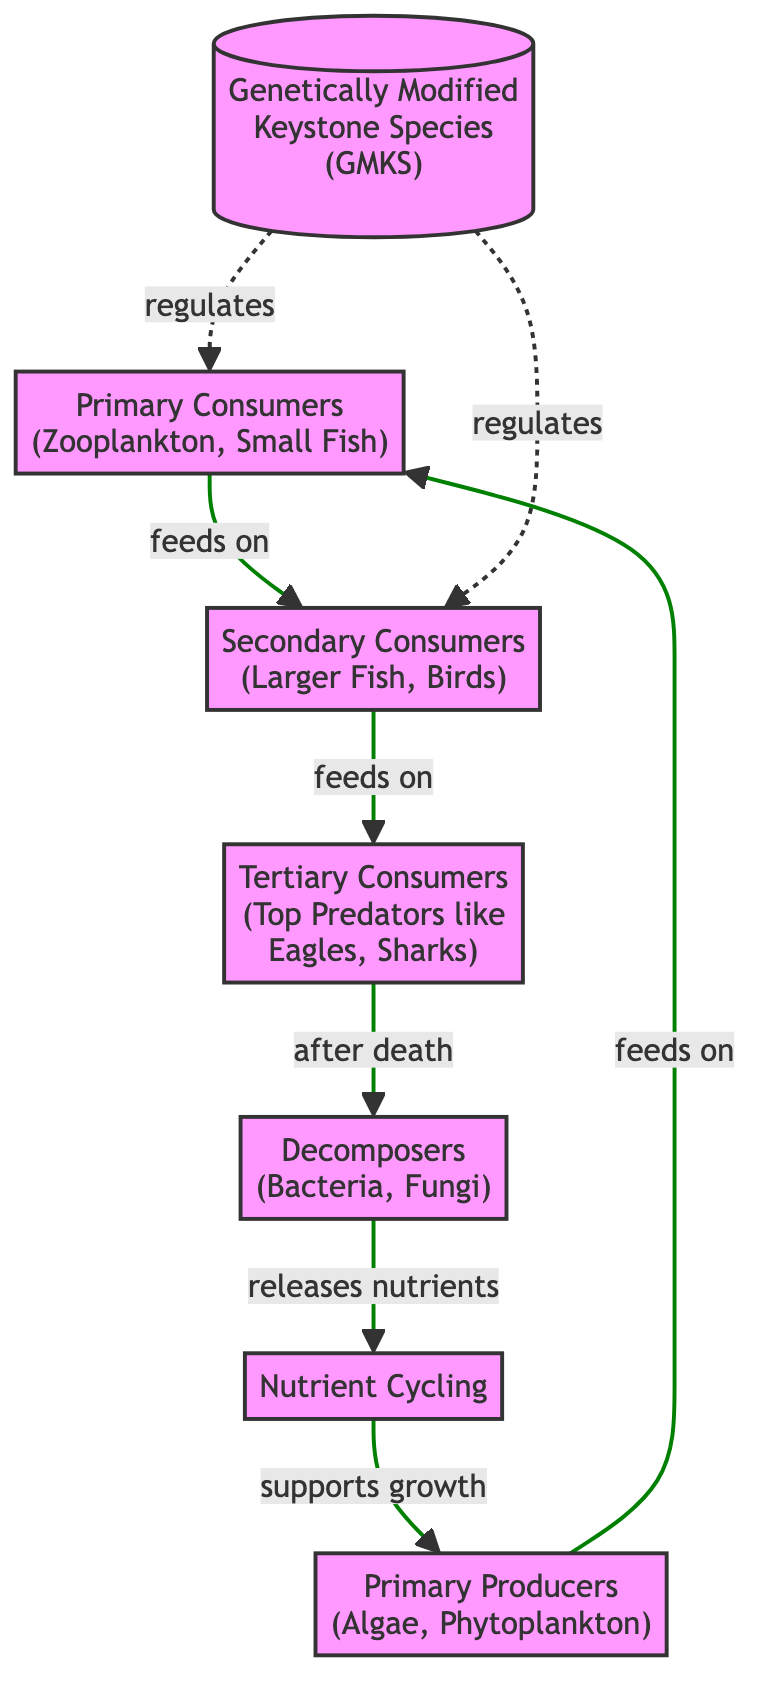What is the starting node of the food chain? The starting node is the Genetically Modified Keystone Species, which is the first element in the flowchart that other nodes depend on for regulation.
Answer: Genetically Modified Keystone Species How many primary consumers are there in the diagram? The diagram displays one primary consumer category, indicated as "Primary Consumers". There are no separate nodes listed as multiple entities under this category.
Answer: 1 What do the primary producers feed on? Primary producers, represented in the diagram as algae and phytoplankton, are fed upon by primary consumers like zooplankton and small fish, depicted by the directed edges connecting them.
Answer: Primary Consumers What role do decomposers play in the food chain? Decomposers break down dead material from organisms in the food chain, returning nutrients to the soil and water, which supports the growth of primary producers, as indicated by the relationship in the diagram.
Answer: Nutrient Cycling How do genetically modified keystone species affect secondary consumers? The genetically modified keystone species have a regulatory role over the secondary consumers, as indicated by the dashed connection that suggests they influence the primary production and availability of food for secondary consumers.
Answer: Regulates What follows after the death of tertiary consumers? The diagram illustrates that after the death of tertiary consumers, the detritus is processed by decomposers, thus reintroducing nutrients back into the ecosystem.
Answer: Decomposers How many nodes are there in total in the diagram? The diagram has a total of seven distinct nodes, representing each level of the food chain along with the process of nutrient cycling.
Answer: 7 Which type of organisms are categorized as tertiary consumers in the diagram? Tertiary consumers in the diagram include top predators like eagles and sharks, which are specifically listed under the tertiary consumer category, indicating their position in the food chain.
Answer: Top Predators What is the direction of nutrient flow as indicated in the diagram? The flow of nutrients is shown to circle back from decomposers to primary producers, establishing a continuous cycle of nutrient cycling that supports ecosystem health.
Answer: Supports growth 